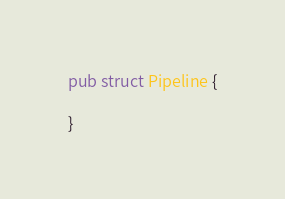Convert code to text. <code><loc_0><loc_0><loc_500><loc_500><_Rust_>
pub struct Pipeline {
    
}</code> 